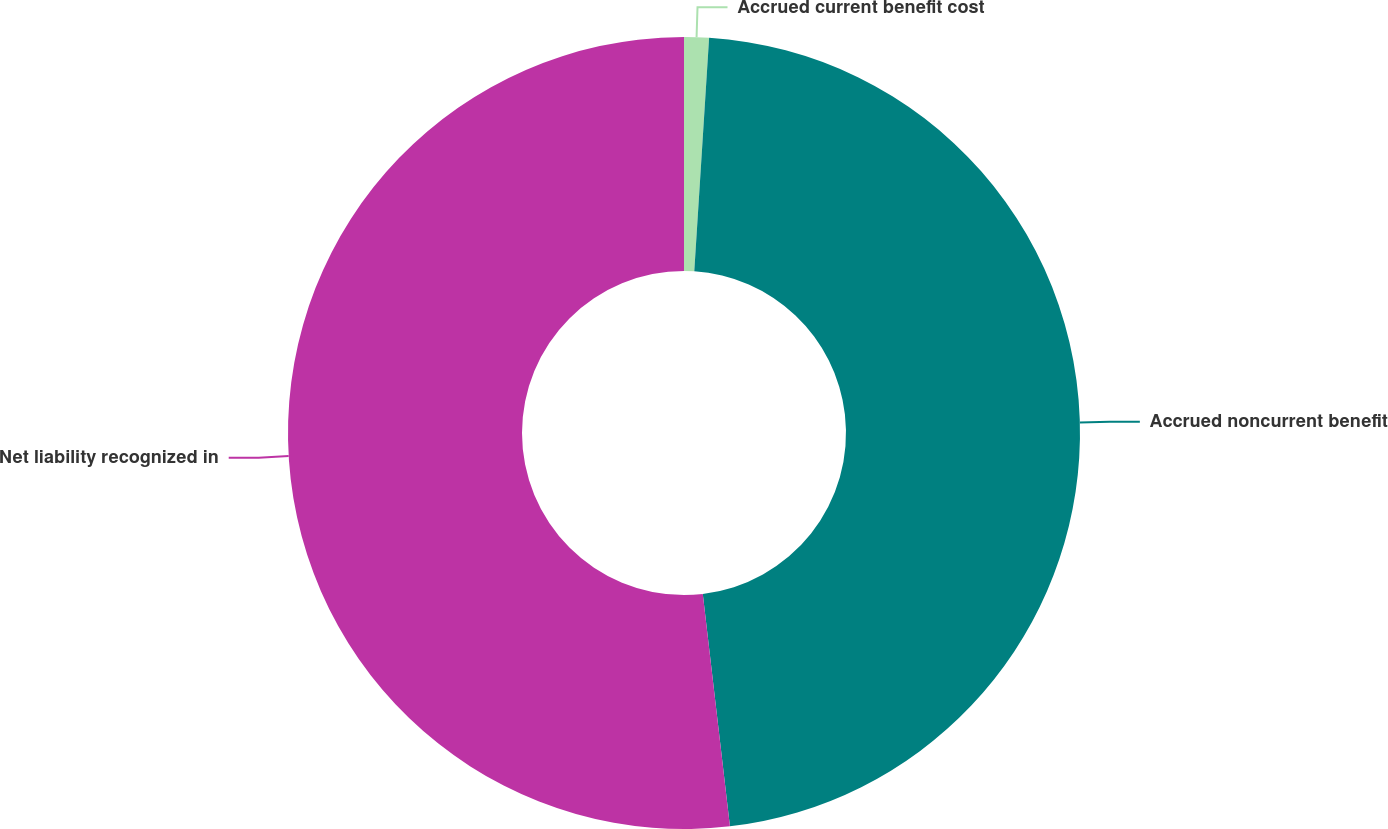Convert chart to OTSL. <chart><loc_0><loc_0><loc_500><loc_500><pie_chart><fcel>Accrued current benefit cost<fcel>Accrued noncurrent benefit<fcel>Net liability recognized in<nl><fcel>1.01%<fcel>47.14%<fcel>51.85%<nl></chart> 